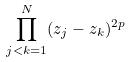<formula> <loc_0><loc_0><loc_500><loc_500>\prod _ { j < k = 1 } ^ { N } ( z _ { j } - z _ { k } ) ^ { 2 p }</formula> 